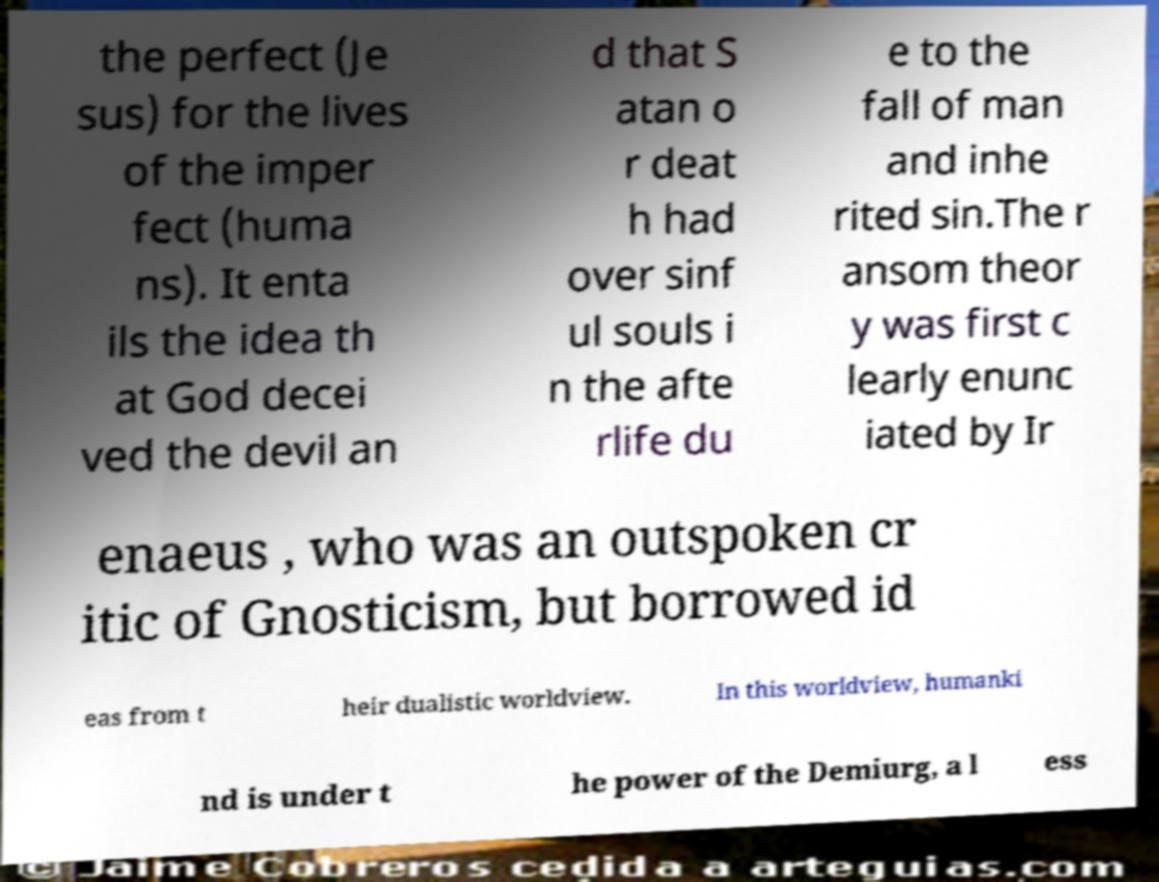I need the written content from this picture converted into text. Can you do that? the perfect (Je sus) for the lives of the imper fect (huma ns). It enta ils the idea th at God decei ved the devil an d that S atan o r deat h had over sinf ul souls i n the afte rlife du e to the fall of man and inhe rited sin.The r ansom theor y was first c learly enunc iated by Ir enaeus , who was an outspoken cr itic of Gnosticism, but borrowed id eas from t heir dualistic worldview. In this worldview, humanki nd is under t he power of the Demiurg, a l ess 